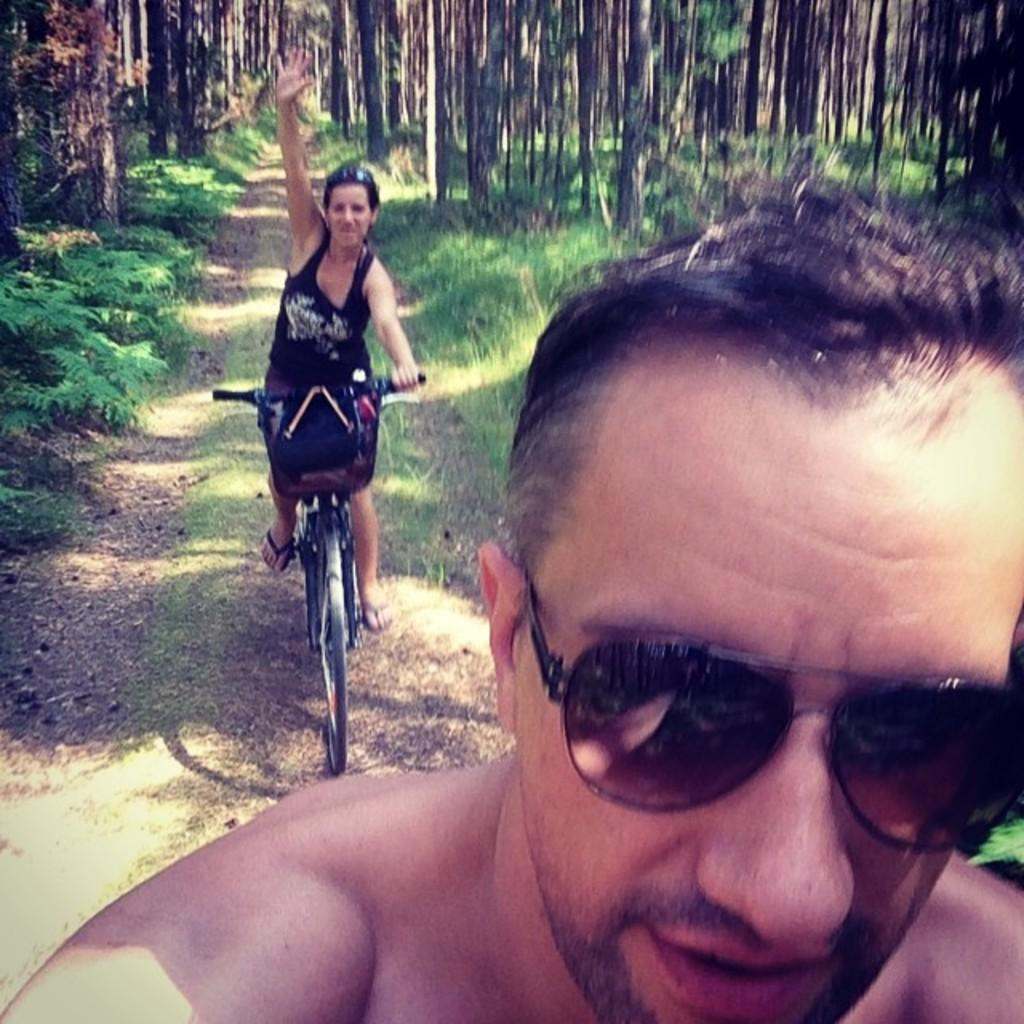What is the person in the foreground of the image wearing? The person in the foreground of the image is wearing sunglasses. What is the person in the background of the image doing? The person in the background of the image is riding a bicycle. What type of vegetation can be seen in the image? There are trees, plants, and grass visible in the image. What is the surface on which the bicycle is riding? There is a road in the image on which the bicycle is riding. What type of selection is available at the bath in the image? There is no bath present in the image, so there is no selection available. 